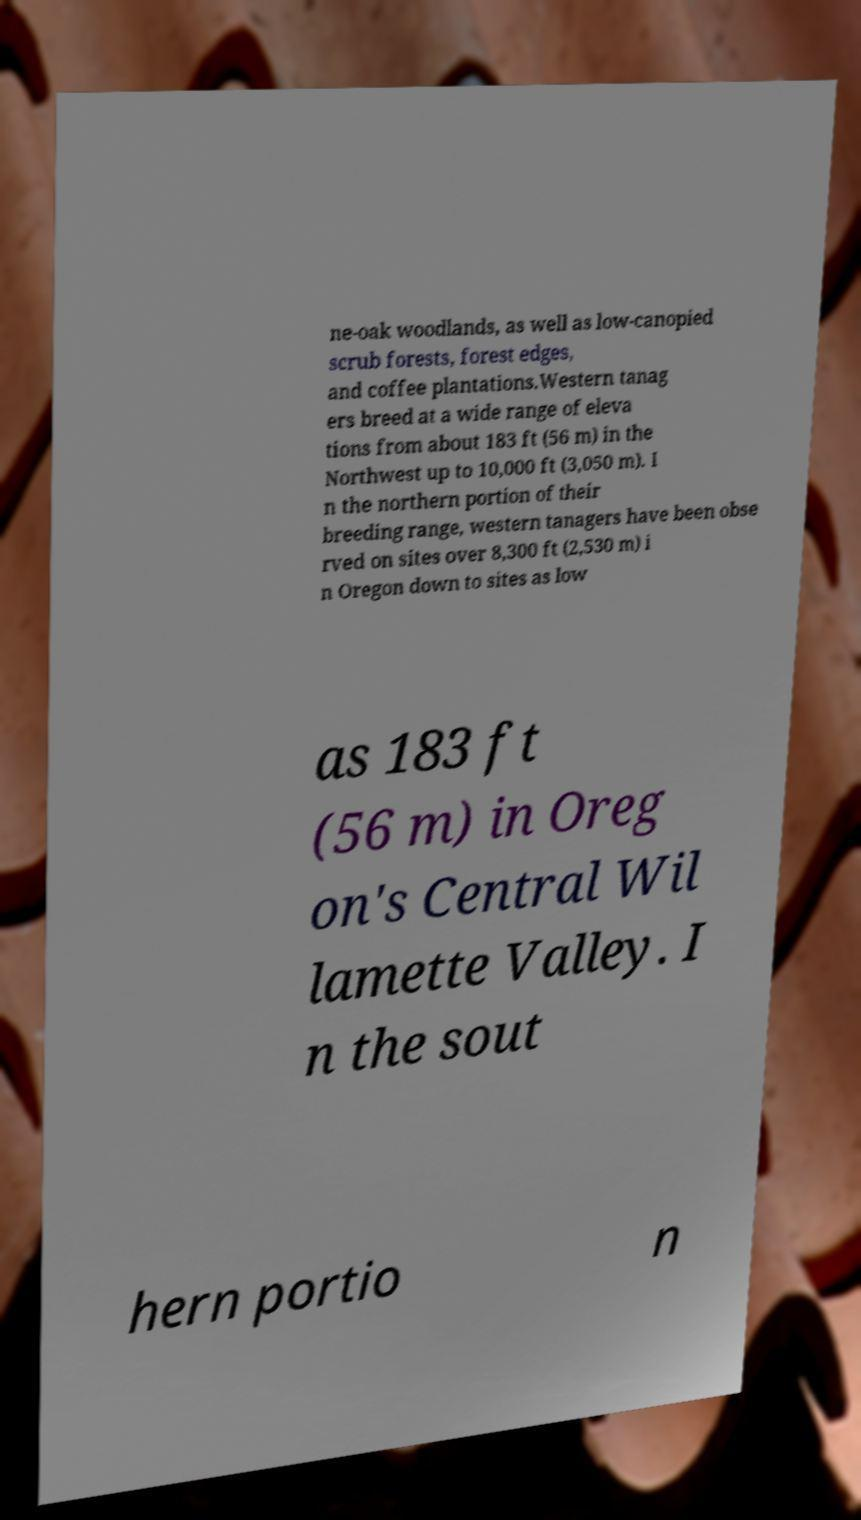For documentation purposes, I need the text within this image transcribed. Could you provide that? ne-oak woodlands, as well as low-canopied scrub forests, forest edges, and coffee plantations.Western tanag ers breed at a wide range of eleva tions from about 183 ft (56 m) in the Northwest up to 10,000 ft (3,050 m). I n the northern portion of their breeding range, western tanagers have been obse rved on sites over 8,300 ft (2,530 m) i n Oregon down to sites as low as 183 ft (56 m) in Oreg on's Central Wil lamette Valley. I n the sout hern portio n 